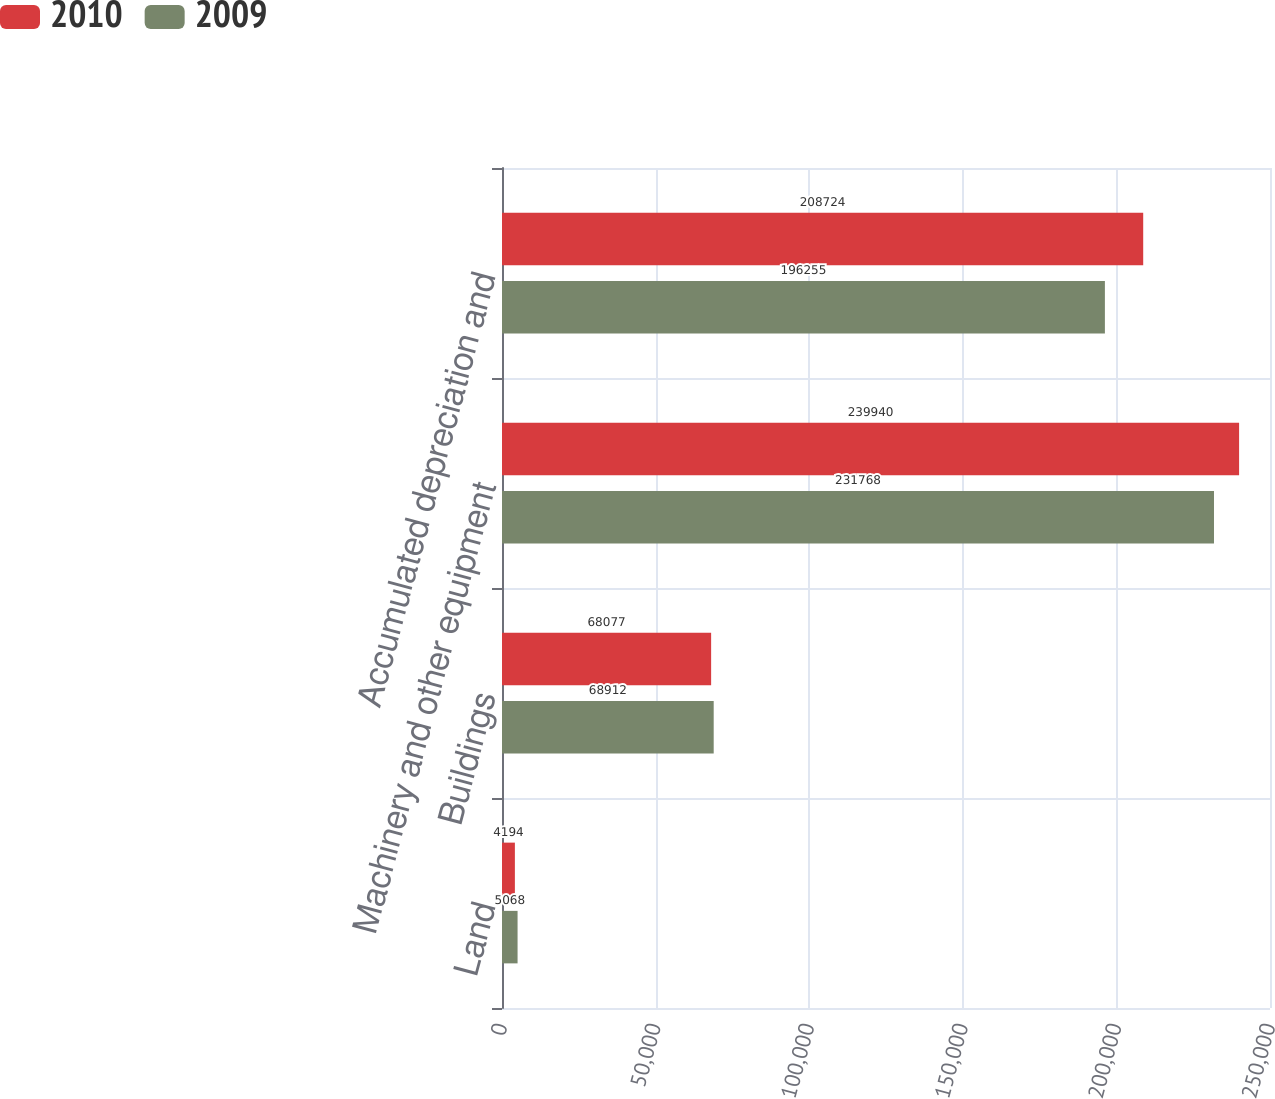Convert chart. <chart><loc_0><loc_0><loc_500><loc_500><stacked_bar_chart><ecel><fcel>Land<fcel>Buildings<fcel>Machinery and other equipment<fcel>Accumulated depreciation and<nl><fcel>2010<fcel>4194<fcel>68077<fcel>239940<fcel>208724<nl><fcel>2009<fcel>5068<fcel>68912<fcel>231768<fcel>196255<nl></chart> 